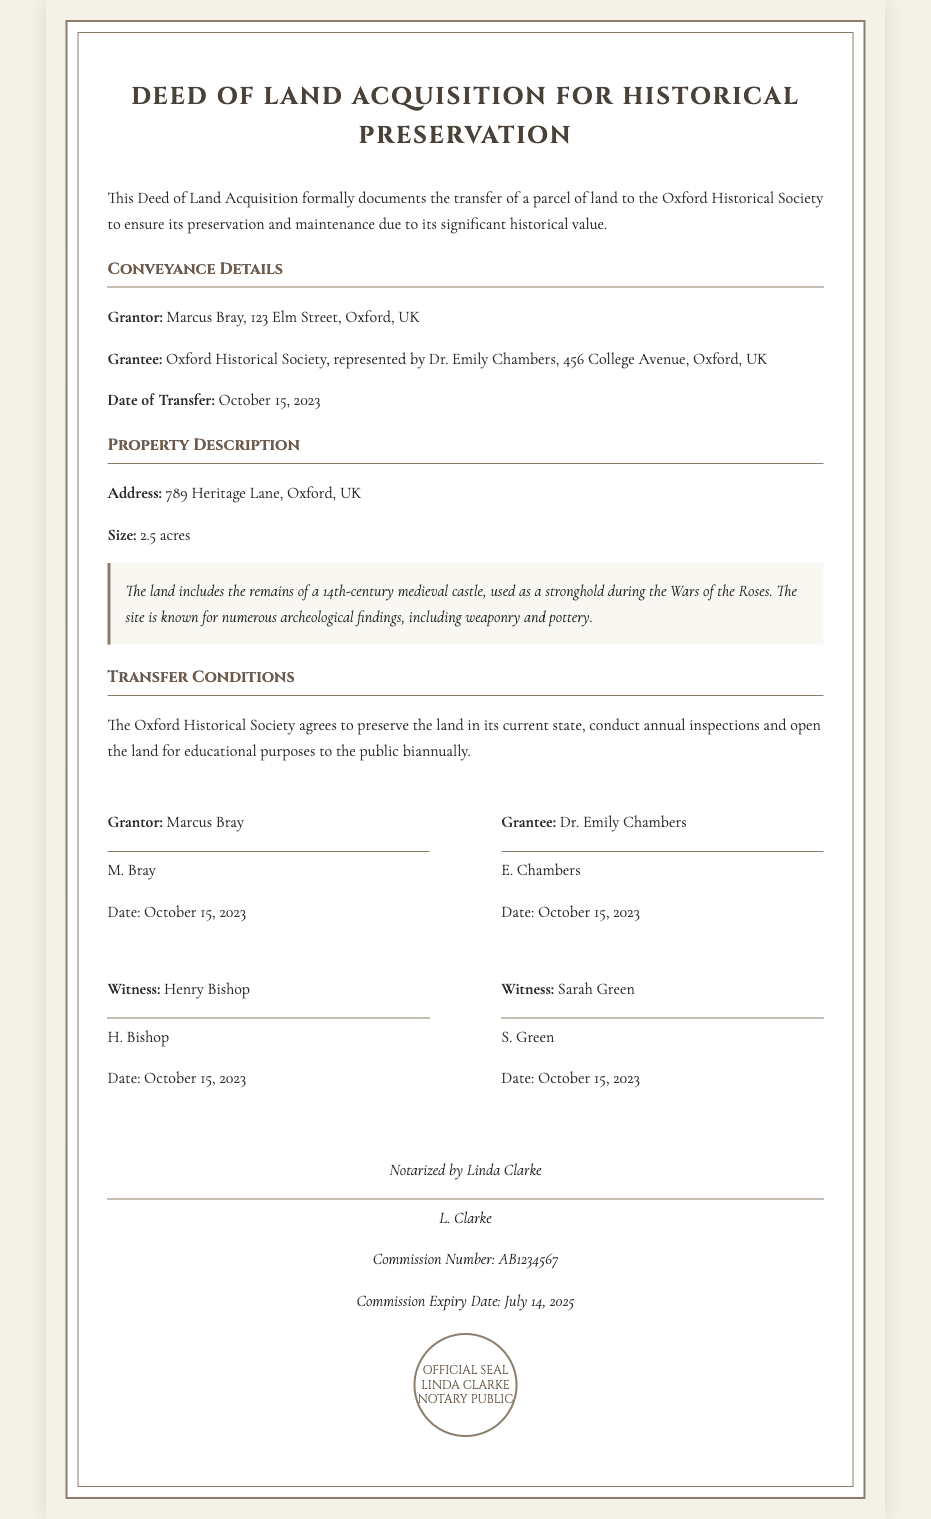What is the title of the document? The title of the document is prominently displayed at the top of the deed.
Answer: Deed of Land Acquisition for Historical Preservation Who is the grantor? The individual granting the land is clearly identified in the conveyance details section.
Answer: Marcus Bray What is the address of the property? The deed provides the specific address of the land being conveyed.
Answer: 789 Heritage Lane, Oxford, UK What is the size of the land? The size of the land is mentioned in the property description.
Answer: 2.5 acres What is the date of transfer? The date when the transfer of land took place is noted in the conveyance details.
Answer: October 15, 2023 What significant historical feature does the land contain? The document describes a notable historical element associated with the parcel of land.
Answer: remains of a 14th-century medieval castle What is the main obligation of the grantee? The deed outlines the primary responsibility that the grantee must fulfill regarding the land.
Answer: preserve the land in its current state How many witnesses signed the deed? The number of witnesses is mentioned in the signature section of the document.
Answer: 2 What is the name of the notary? The notary who notarized the document is specified at the end.
Answer: Linda Clarke What is the commission expiry date for the notary? The deed includes the expiration date of the notary's commission.
Answer: July 14, 2025 